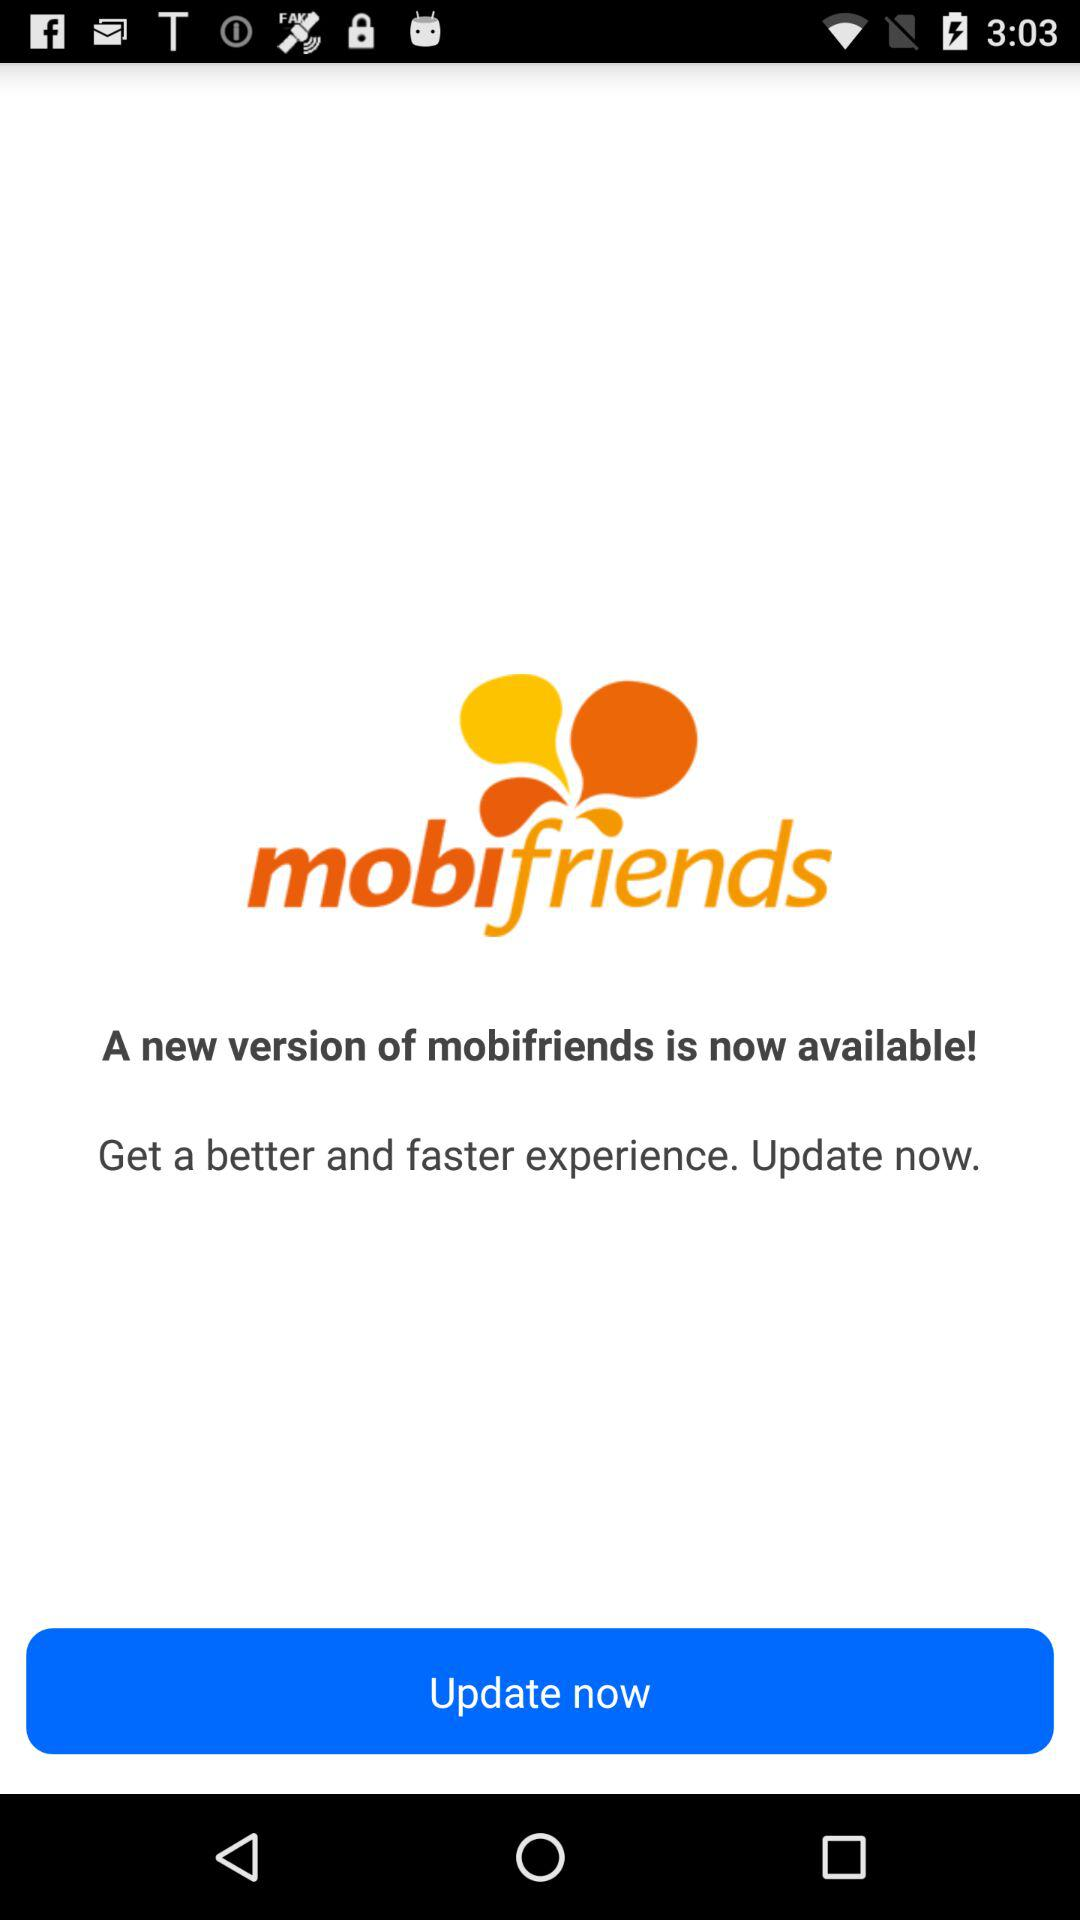What is the name of the application? The name of the application is "mobifriends". 